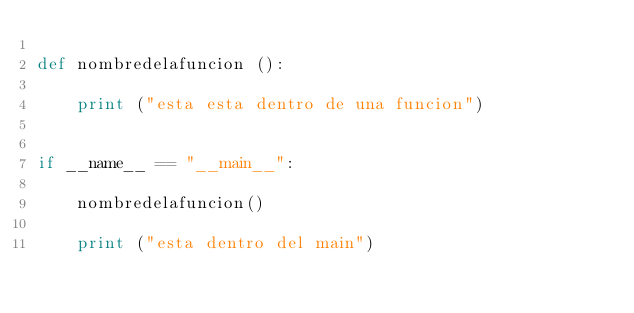Convert code to text. <code><loc_0><loc_0><loc_500><loc_500><_Python_>
def nombredelafuncion ():

	print ("esta esta dentro de una funcion")


if __name__ == "__main__":

	nombredelafuncion()

	print ("esta dentro del main")

	</code> 